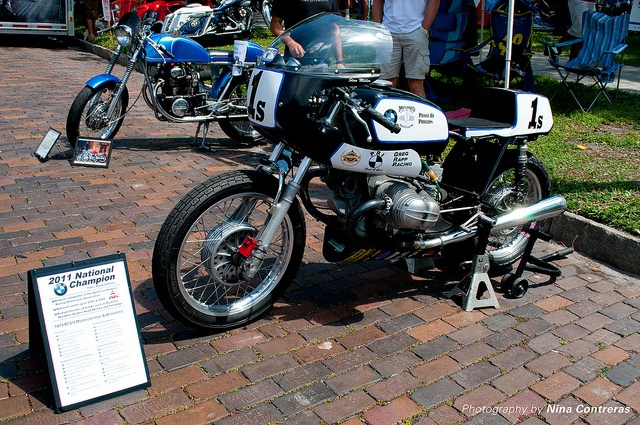Describe the objects in this image and their specific colors. I can see motorcycle in gray, black, white, and darkgray tones, motorcycle in gray, black, darkgray, and blue tones, chair in gray, black, navy, and blue tones, people in gray, maroon, and darkgray tones, and people in gray, black, maroon, and teal tones in this image. 